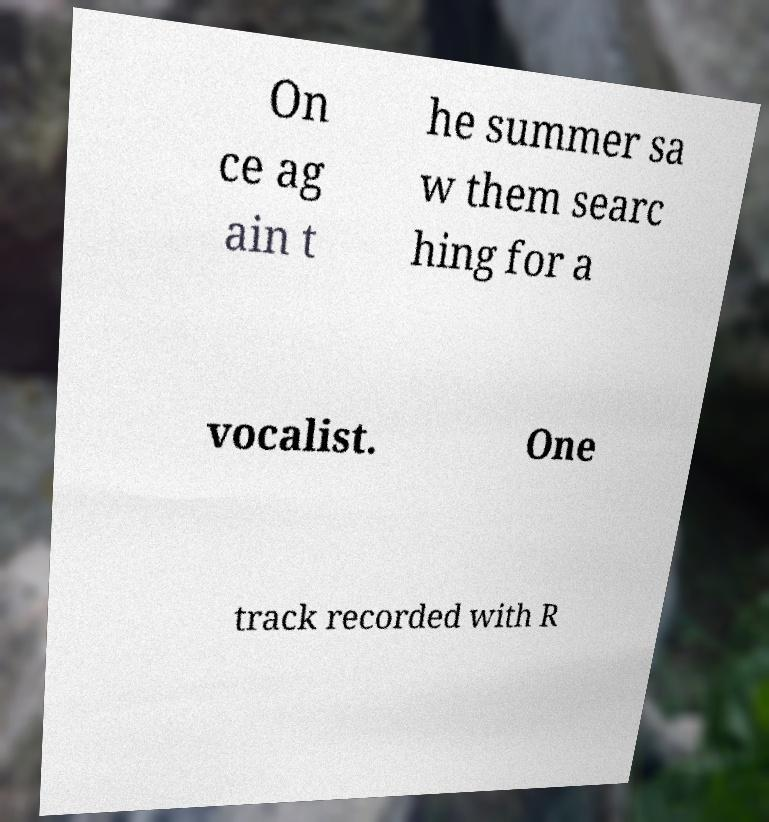There's text embedded in this image that I need extracted. Can you transcribe it verbatim? On ce ag ain t he summer sa w them searc hing for a vocalist. One track recorded with R 